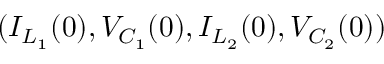Convert formula to latex. <formula><loc_0><loc_0><loc_500><loc_500>( I _ { L _ { 1 } } ( 0 ) , V _ { C _ { 1 } } ( 0 ) , I _ { L _ { 2 } } ( 0 ) , V _ { C _ { 2 } } ( 0 ) )</formula> 